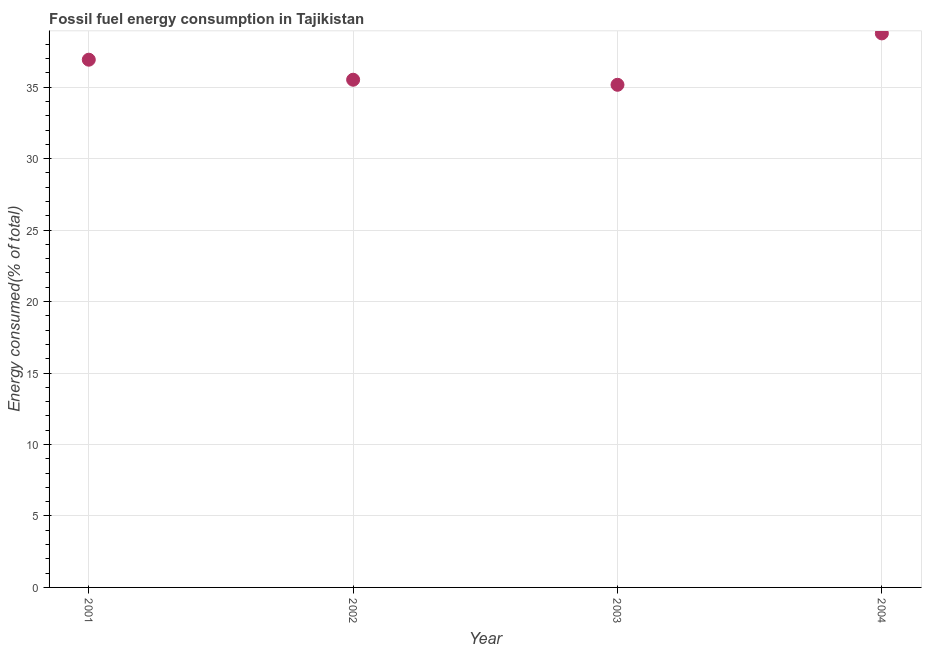What is the fossil fuel energy consumption in 2004?
Keep it short and to the point. 38.76. Across all years, what is the maximum fossil fuel energy consumption?
Offer a very short reply. 38.76. Across all years, what is the minimum fossil fuel energy consumption?
Your answer should be very brief. 35.17. In which year was the fossil fuel energy consumption maximum?
Give a very brief answer. 2004. In which year was the fossil fuel energy consumption minimum?
Your response must be concise. 2003. What is the sum of the fossil fuel energy consumption?
Keep it short and to the point. 146.38. What is the difference between the fossil fuel energy consumption in 2001 and 2004?
Provide a succinct answer. -1.84. What is the average fossil fuel energy consumption per year?
Keep it short and to the point. 36.59. What is the median fossil fuel energy consumption?
Your answer should be very brief. 36.22. What is the ratio of the fossil fuel energy consumption in 2002 to that in 2004?
Keep it short and to the point. 0.92. Is the fossil fuel energy consumption in 2001 less than that in 2004?
Your answer should be very brief. Yes. What is the difference between the highest and the second highest fossil fuel energy consumption?
Your answer should be very brief. 1.84. Is the sum of the fossil fuel energy consumption in 2002 and 2003 greater than the maximum fossil fuel energy consumption across all years?
Offer a very short reply. Yes. What is the difference between the highest and the lowest fossil fuel energy consumption?
Your answer should be compact. 3.6. Does the fossil fuel energy consumption monotonically increase over the years?
Make the answer very short. No. How many years are there in the graph?
Give a very brief answer. 4. What is the difference between two consecutive major ticks on the Y-axis?
Provide a short and direct response. 5. Are the values on the major ticks of Y-axis written in scientific E-notation?
Give a very brief answer. No. Does the graph contain grids?
Your answer should be very brief. Yes. What is the title of the graph?
Offer a terse response. Fossil fuel energy consumption in Tajikistan. What is the label or title of the X-axis?
Ensure brevity in your answer.  Year. What is the label or title of the Y-axis?
Make the answer very short. Energy consumed(% of total). What is the Energy consumed(% of total) in 2001?
Your response must be concise. 36.92. What is the Energy consumed(% of total) in 2002?
Offer a very short reply. 35.52. What is the Energy consumed(% of total) in 2003?
Provide a short and direct response. 35.17. What is the Energy consumed(% of total) in 2004?
Give a very brief answer. 38.76. What is the difference between the Energy consumed(% of total) in 2001 and 2002?
Ensure brevity in your answer.  1.4. What is the difference between the Energy consumed(% of total) in 2001 and 2003?
Keep it short and to the point. 1.76. What is the difference between the Energy consumed(% of total) in 2001 and 2004?
Offer a terse response. -1.84. What is the difference between the Energy consumed(% of total) in 2002 and 2003?
Ensure brevity in your answer.  0.35. What is the difference between the Energy consumed(% of total) in 2002 and 2004?
Your response must be concise. -3.24. What is the difference between the Energy consumed(% of total) in 2003 and 2004?
Ensure brevity in your answer.  -3.6. What is the ratio of the Energy consumed(% of total) in 2001 to that in 2002?
Provide a short and direct response. 1.04. What is the ratio of the Energy consumed(% of total) in 2001 to that in 2003?
Make the answer very short. 1.05. What is the ratio of the Energy consumed(% of total) in 2001 to that in 2004?
Provide a short and direct response. 0.95. What is the ratio of the Energy consumed(% of total) in 2002 to that in 2003?
Provide a short and direct response. 1.01. What is the ratio of the Energy consumed(% of total) in 2002 to that in 2004?
Your answer should be compact. 0.92. What is the ratio of the Energy consumed(% of total) in 2003 to that in 2004?
Make the answer very short. 0.91. 